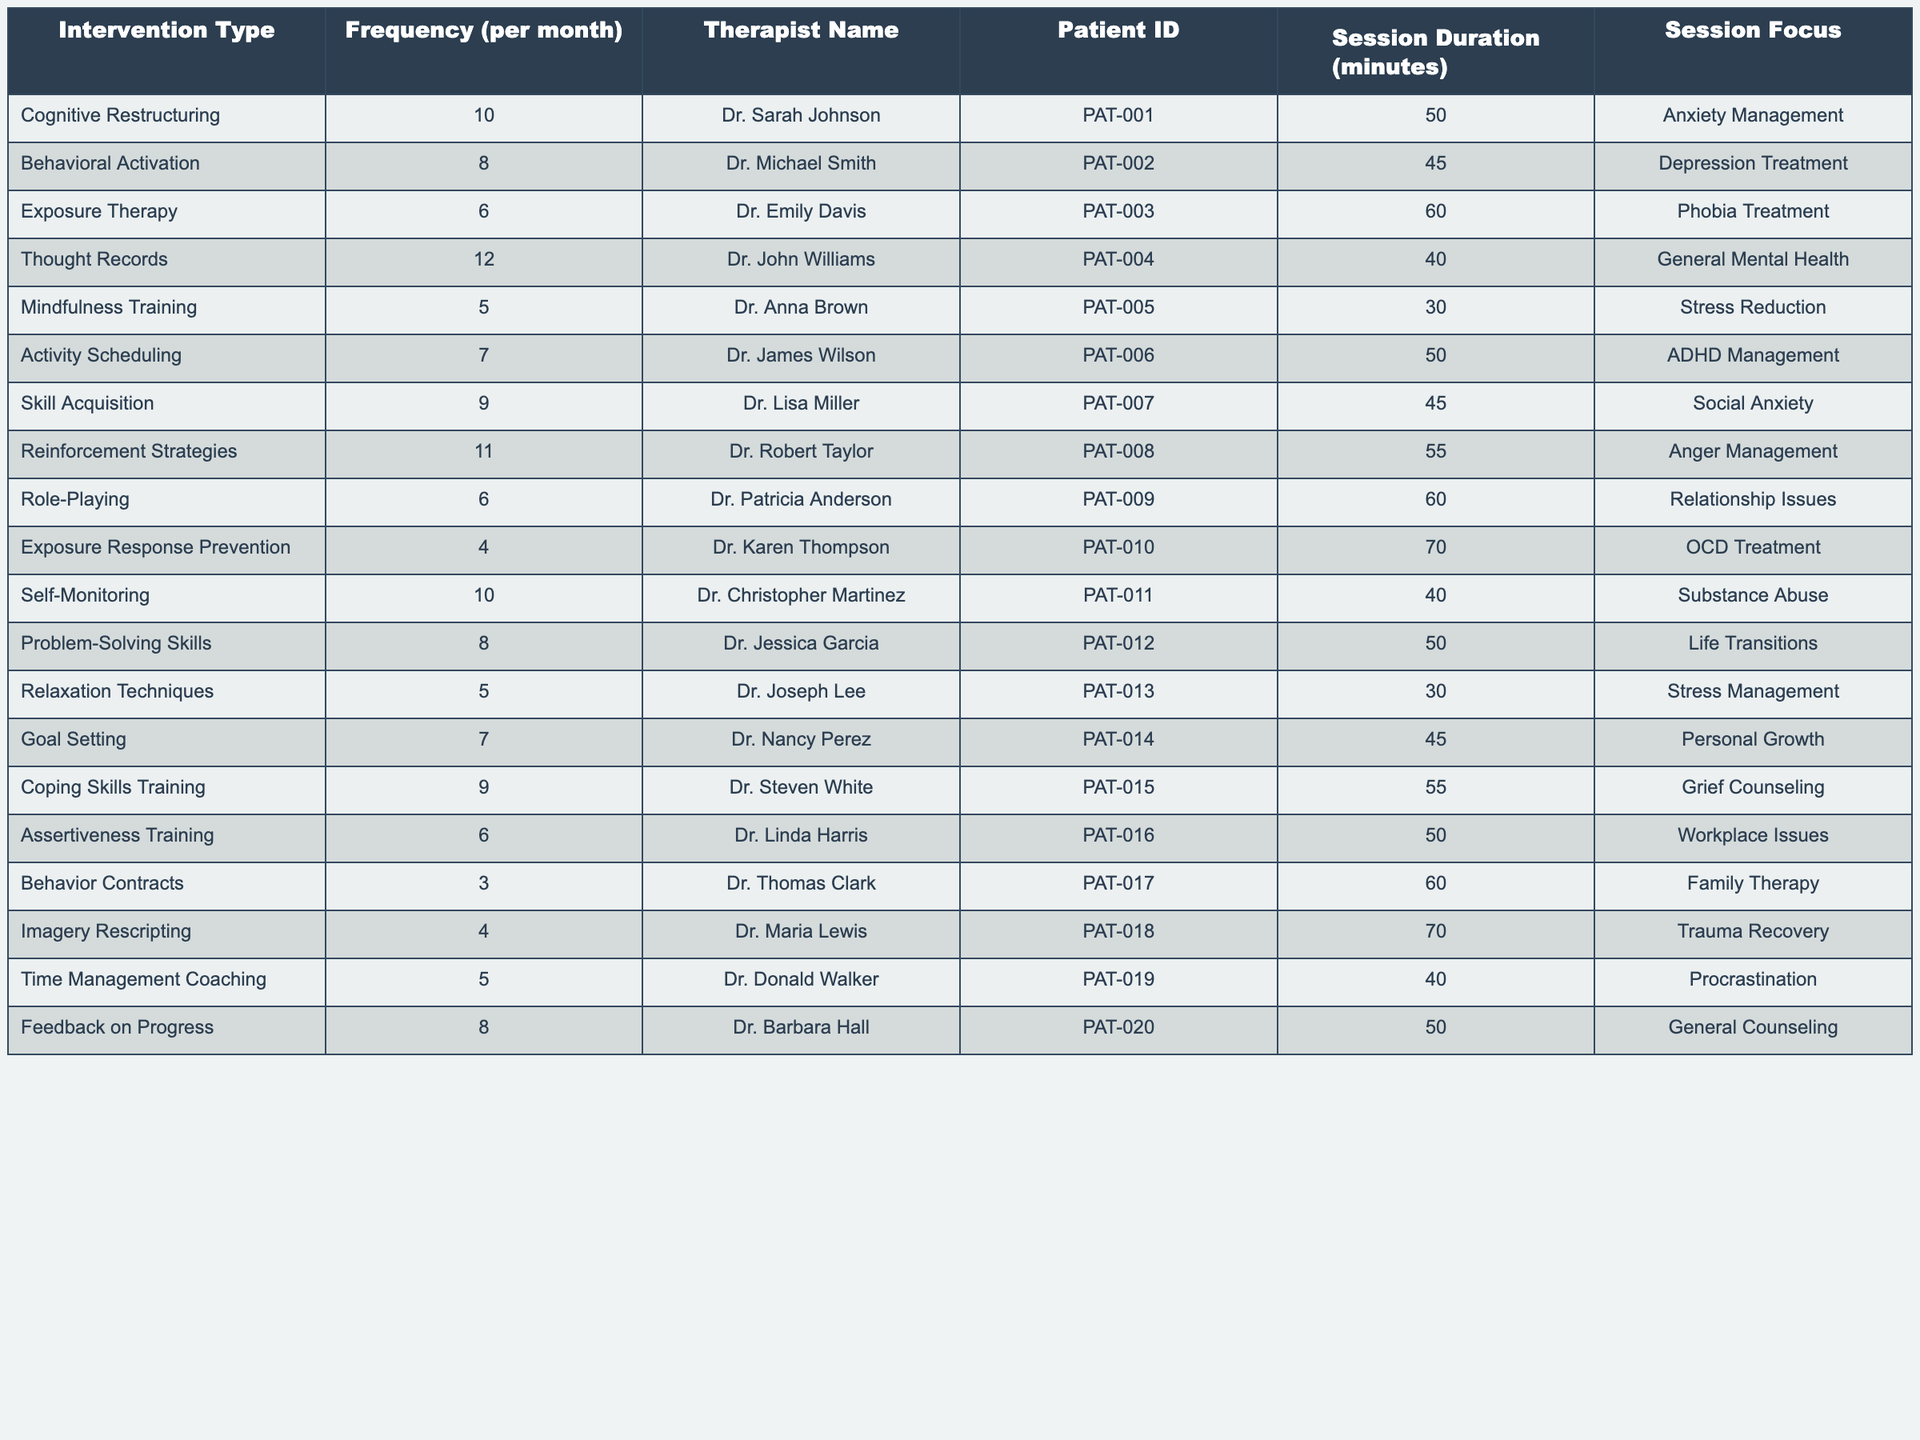What is the most frequently applied intervention type? By scanning the "Frequency (per month)" column, we can see that "Thought Records" has the highest value at 12 sessions.
Answer: Thought Records Which therapist applied the least frequent intervention? Looking at the "Frequency (per month)" column, "Behavior Contracts" has the lowest value of 3 sessions, which is associated with Dr. Thomas Clark.
Answer: Dr. Thomas Clark How many different interventions are applied for anxiety management? Reviewing the "Session Focus" column, there is only one intervention labeled "Anxiety Management" which is "Cognitive Restructuring."
Answer: 1 What is the average frequency of all interventions combined? To find the average, we sum all the frequencies (10+8+6+12+5+7+9+11+6+4+10+8+5+7+9+6+3+4+5+8) = 151, and then divide by the number of interventions (20): 151/20 = 7.55.
Answer: 7.55 How many minutes is the longest single therapy session? From the "Session Duration (minutes)" column, we see that "Exposure Therapy" had the longest session lasting 70 minutes.
Answer: 70 Are there any interventions led by more than one therapist? By reviewing the table, it is clear that each intervention type is unique to a specific therapist, indicating no interventions are shared by multiple therapists.
Answer: No What is the total frequency of interventions focusing on stress management? The "Session Focus" column indicates "Mindfulness Training" and "Relaxation Techniques" address stress management. Adding their frequencies (5 + 5) gives a total of 10.
Answer: 10 Which type of intervention has the longest average session duration? The session durations for "Exposure Therapy" (60 minutes), "OCD Treatment" (70 minutes) and "Imagery Rescripting" (70 minutes) are notable. Analyzing the sessions with the longest durations yields a maximum of 70 minutes, thus "Imagery Rescripting" and "Exposure Response Prevention" have the longest durations.
Answer: 70 How many therapists focus on personal growth? Checking the "Session Focus," we discover that only Dr. Nancy Perez is focusing on personal growth through "Goal Setting," making it a total of 1 therapist.
Answer: 1 What percentage of interventions focus on mental health or related issues? Count the number of interventions addressing "Anxiety Management," "Depression Treatment," "General Mental Health," "Stress Reduction," and "Grief Counseling" which gives us 5 out of 20, thus the calculation is (5/20) * 100 = 25%.
Answer: 25% 